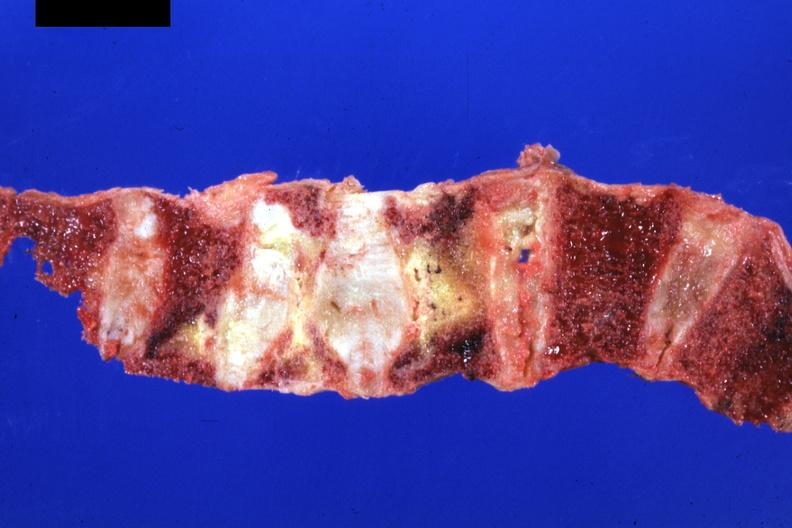s joints present?
Answer the question using a single word or phrase. Yes 